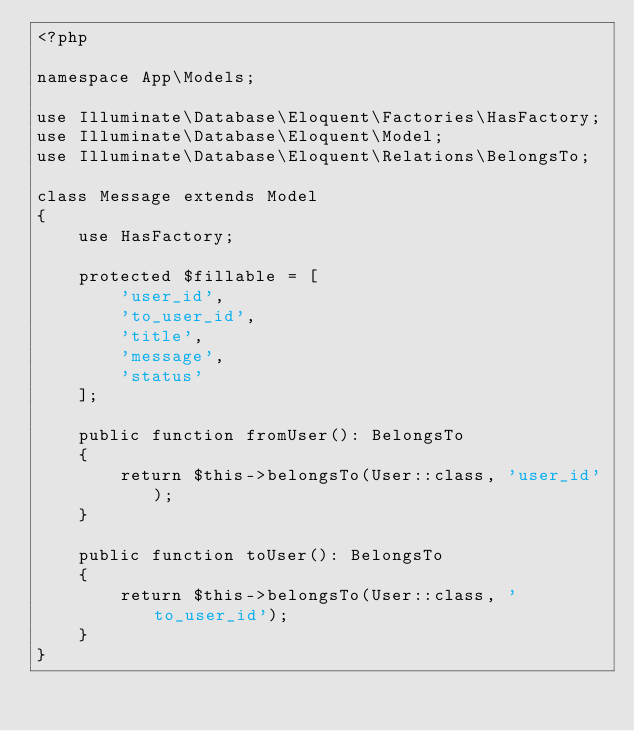Convert code to text. <code><loc_0><loc_0><loc_500><loc_500><_PHP_><?php

namespace App\Models;

use Illuminate\Database\Eloquent\Factories\HasFactory;
use Illuminate\Database\Eloquent\Model;
use Illuminate\Database\Eloquent\Relations\BelongsTo;

class Message extends Model
{
    use HasFactory;

    protected $fillable = [
        'user_id',
        'to_user_id',
        'title',
        'message',
        'status'
    ];

    public function fromUser(): BelongsTo
    {
        return $this->belongsTo(User::class, 'user_id');
    }

    public function toUser(): BelongsTo
    {
        return $this->belongsTo(User::class, 'to_user_id');
    }
}
</code> 